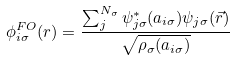Convert formula to latex. <formula><loc_0><loc_0><loc_500><loc_500>\phi _ { i \sigma } ^ { F O } ( r ) = \frac { \sum _ { j } ^ { N _ { \sigma } } \psi _ { j \sigma } ^ { * } ( { a } _ { i \sigma } ) \psi _ { j \sigma } ( \vec { r } ) } { \sqrt { \rho _ { \sigma } ( { a } _ { i \sigma } ) } }</formula> 